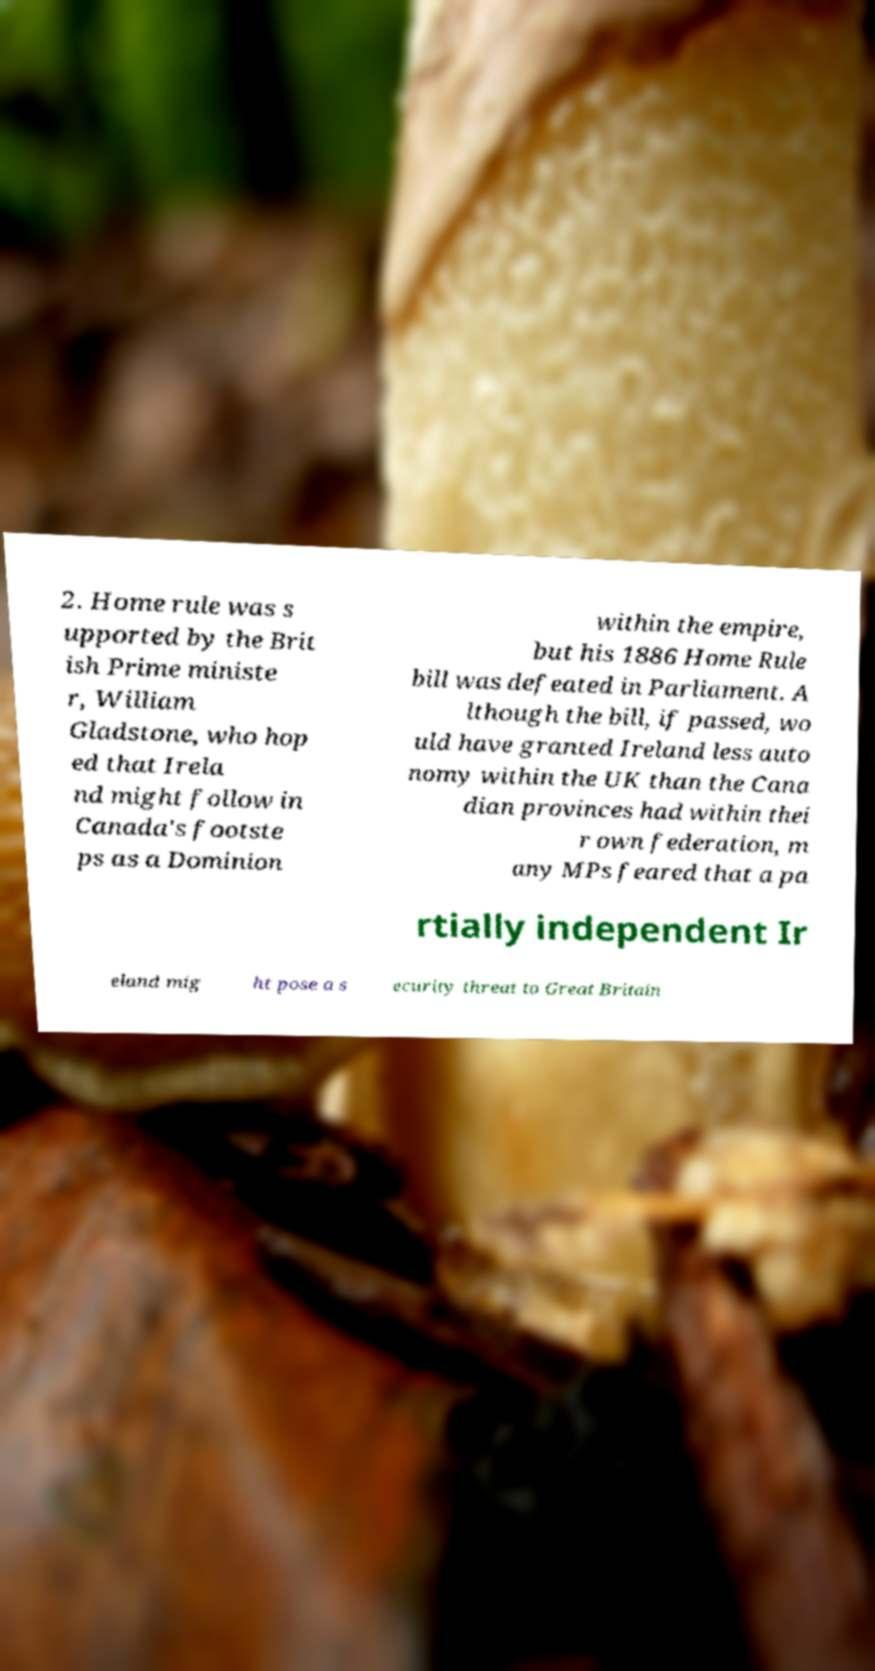I need the written content from this picture converted into text. Can you do that? 2. Home rule was s upported by the Brit ish Prime ministe r, William Gladstone, who hop ed that Irela nd might follow in Canada's footste ps as a Dominion within the empire, but his 1886 Home Rule bill was defeated in Parliament. A lthough the bill, if passed, wo uld have granted Ireland less auto nomy within the UK than the Cana dian provinces had within thei r own federation, m any MPs feared that a pa rtially independent Ir eland mig ht pose a s ecurity threat to Great Britain 